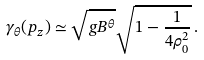Convert formula to latex. <formula><loc_0><loc_0><loc_500><loc_500>\gamma _ { \theta } ( p _ { z } ) \simeq \sqrt { g B ^ { \theta } } \sqrt { 1 - \frac { 1 } { 4 \rho _ { 0 } ^ { 2 } } } \, .</formula> 